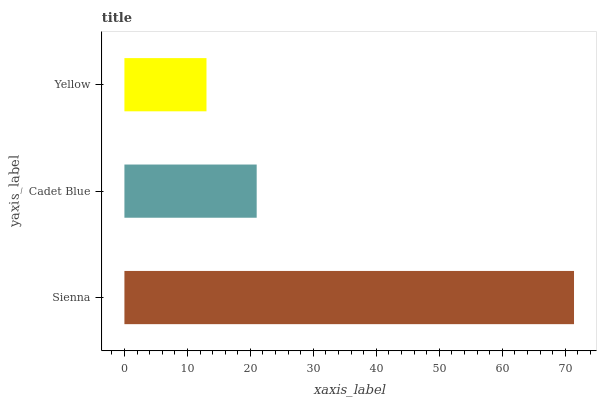Is Yellow the minimum?
Answer yes or no. Yes. Is Sienna the maximum?
Answer yes or no. Yes. Is Cadet Blue the minimum?
Answer yes or no. No. Is Cadet Blue the maximum?
Answer yes or no. No. Is Sienna greater than Cadet Blue?
Answer yes or no. Yes. Is Cadet Blue less than Sienna?
Answer yes or no. Yes. Is Cadet Blue greater than Sienna?
Answer yes or no. No. Is Sienna less than Cadet Blue?
Answer yes or no. No. Is Cadet Blue the high median?
Answer yes or no. Yes. Is Cadet Blue the low median?
Answer yes or no. Yes. Is Yellow the high median?
Answer yes or no. No. Is Yellow the low median?
Answer yes or no. No. 